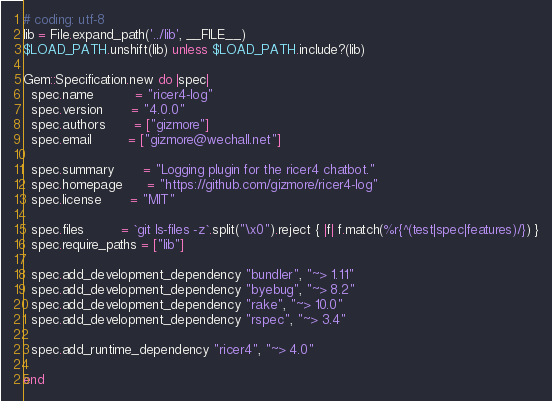<code> <loc_0><loc_0><loc_500><loc_500><_Ruby_># coding: utf-8
lib = File.expand_path('../lib', __FILE__)
$LOAD_PATH.unshift(lib) unless $LOAD_PATH.include?(lib)

Gem::Specification.new do |spec|
  spec.name          = "ricer4-log"
  spec.version       = "4.0.0"
  spec.authors       = ["gizmore"]
  spec.email         = ["gizmore@wechall.net"]

  spec.summary       = "Logging plugin for the ricer4 chatbot."
  spec.homepage      = "https://github.com/gizmore/ricer4-log"
  spec.license       = "MIT"

  spec.files         = `git ls-files -z`.split("\x0").reject { |f| f.match(%r{^(test|spec|features)/}) }
  spec.require_paths = ["lib"]

  spec.add_development_dependency "bundler", "~> 1.11"
  spec.add_development_dependency "byebug", "~> 8.2"
  spec.add_development_dependency "rake", "~> 10.0"
  spec.add_development_dependency "rspec", "~> 3.4"

  spec.add_runtime_dependency "ricer4", "~> 4.0"

end
</code> 